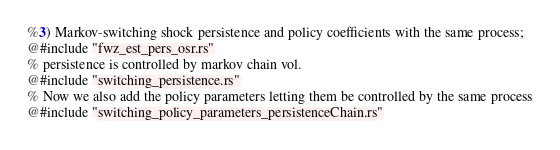Convert code to text. <code><loc_0><loc_0><loc_500><loc_500><_Rust_>
%3) Markov-switching shock persistence and policy coefficients with the same process;
@#include "fwz_est_pers_osr.rs"
% persistence is controlled by markov chain vol.
@#include "switching_persistence.rs"
% Now we also add the policy parameters letting them be controlled by the same process
@#include "switching_policy_parameters_persistenceChain.rs"

</code> 